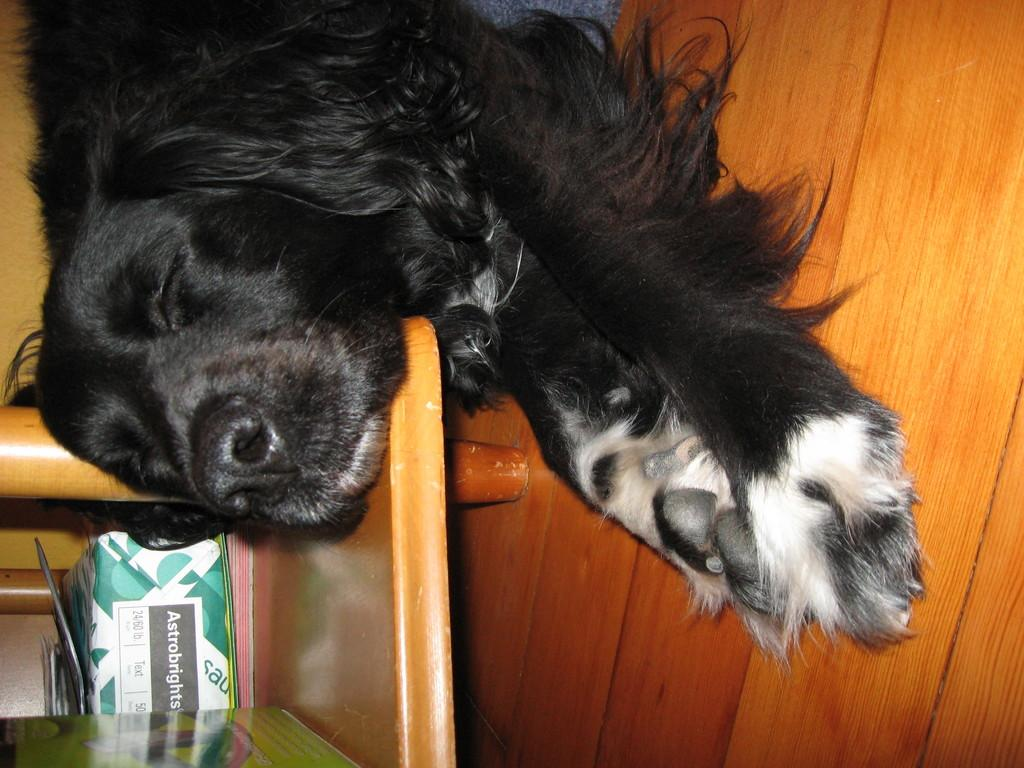What type of animal is in the image? There is a black dog in the image. What is the dog doing in the image? The dog is sleeping on a platform. Are there any objects near the dog? Yes, there are objects beside the dog. How many seeds are visible on the dog's fur in the image? There are no seeds visible on the dog's fur in the image. What type of currency is present in the image? There is no mention of currency in the provided facts, so we cannot determine if any is present in the image. 